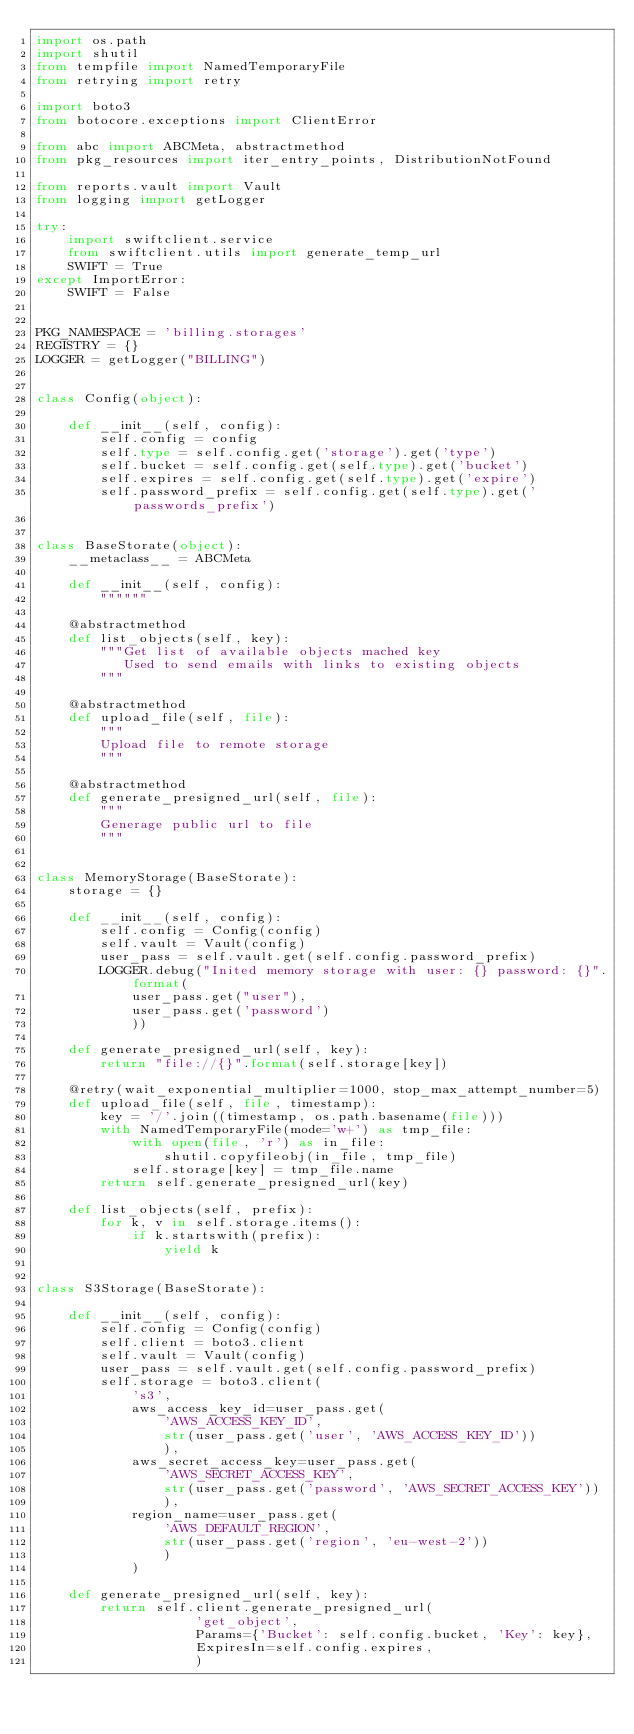<code> <loc_0><loc_0><loc_500><loc_500><_Python_>import os.path
import shutil
from tempfile import NamedTemporaryFile
from retrying import retry

import boto3
from botocore.exceptions import ClientError

from abc import ABCMeta, abstractmethod
from pkg_resources import iter_entry_points, DistributionNotFound

from reports.vault import Vault
from logging import getLogger

try:
    import swiftclient.service
    from swiftclient.utils import generate_temp_url
    SWIFT = True
except ImportError:
    SWIFT = False


PKG_NAMESPACE = 'billing.storages'
REGISTRY = {}
LOGGER = getLogger("BILLING")


class Config(object):

    def __init__(self, config):
        self.config = config
        self.type = self.config.get('storage').get('type')
        self.bucket = self.config.get(self.type).get('bucket')
        self.expires = self.config.get(self.type).get('expire')
        self.password_prefix = self.config.get(self.type).get('passwords_prefix')


class BaseStorate(object):
    __metaclass__ = ABCMeta

    def __init__(self, config):
        """"""

    @abstractmethod
    def list_objects(self, key):
        """Get list of available objects mached key
           Used to send emails with links to existing objects
        """

    @abstractmethod
    def upload_file(self, file):
        """
        Upload file to remote storage
        """

    @abstractmethod
    def generate_presigned_url(self, file):
        """
        Generage public url to file
        """


class MemoryStorage(BaseStorate):
    storage = {}

    def __init__(self, config):
        self.config = Config(config)
        self.vault = Vault(config)
        user_pass = self.vault.get(self.config.password_prefix)
        LOGGER.debug("Inited memory storage with user: {} password: {}".format(
            user_pass.get("user"),
            user_pass.get('password')
            ))

    def generate_presigned_url(self, key):
        return "file://{}".format(self.storage[key])

    @retry(wait_exponential_multiplier=1000, stop_max_attempt_number=5)
    def upload_file(self, file, timestamp):
        key = '/'.join((timestamp, os.path.basename(file)))
        with NamedTemporaryFile(mode='w+') as tmp_file:
            with open(file, 'r') as in_file:
                shutil.copyfileobj(in_file, tmp_file)
            self.storage[key] = tmp_file.name
        return self.generate_presigned_url(key)

    def list_objects(self, prefix):
        for k, v in self.storage.items():
            if k.startswith(prefix):
                yield k


class S3Storage(BaseStorate):

    def __init__(self, config):
        self.config = Config(config)
        self.client = boto3.client
        self.vault = Vault(config)
        user_pass = self.vault.get(self.config.password_prefix)
        self.storage = boto3.client(
            's3',
            aws_access_key_id=user_pass.get(
                'AWS_ACCESS_KEY_ID',
                str(user_pass.get('user', 'AWS_ACCESS_KEY_ID'))
                ),
            aws_secret_access_key=user_pass.get(
                'AWS_SECRET_ACCESS_KEY',
                str(user_pass.get('password', 'AWS_SECRET_ACCESS_KEY'))
                ),
            region_name=user_pass.get(
                'AWS_DEFAULT_REGION',
                str(user_pass.get('region', 'eu-west-2'))
                )
            )

    def generate_presigned_url(self, key):
        return self.client.generate_presigned_url(
                    'get_object',
                    Params={'Bucket': self.config.bucket, 'Key': key},
                    ExpiresIn=self.config.expires,
                    )
</code> 